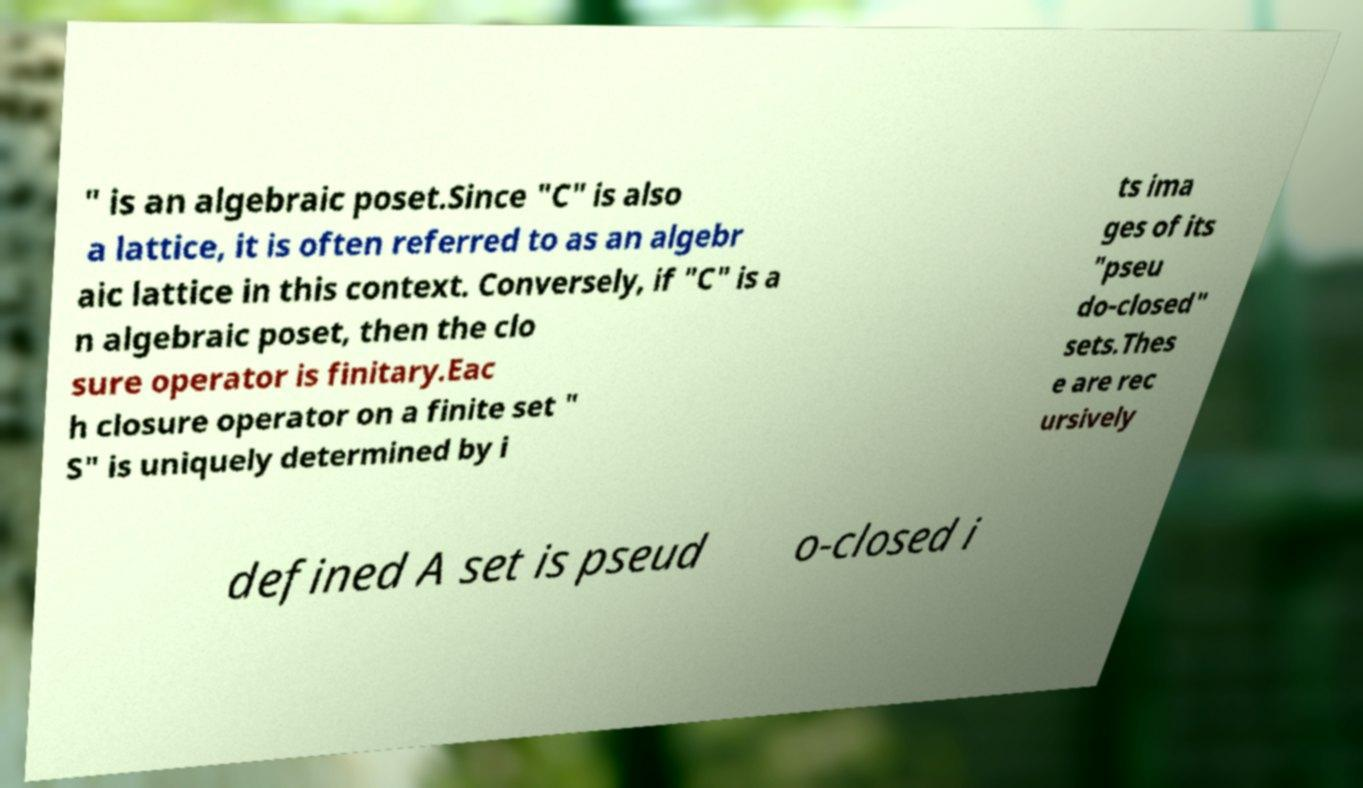Please read and relay the text visible in this image. What does it say? " is an algebraic poset.Since "C" is also a lattice, it is often referred to as an algebr aic lattice in this context. Conversely, if "C" is a n algebraic poset, then the clo sure operator is finitary.Eac h closure operator on a finite set " S" is uniquely determined by i ts ima ges of its "pseu do-closed" sets.Thes e are rec ursively defined A set is pseud o-closed i 